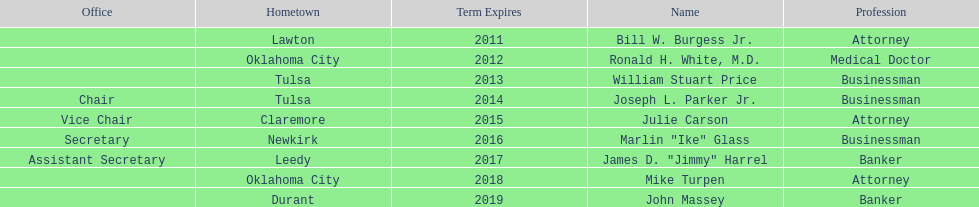Other than william stuart price, which other businessman was born in tulsa? Joseph L. Parker Jr. 